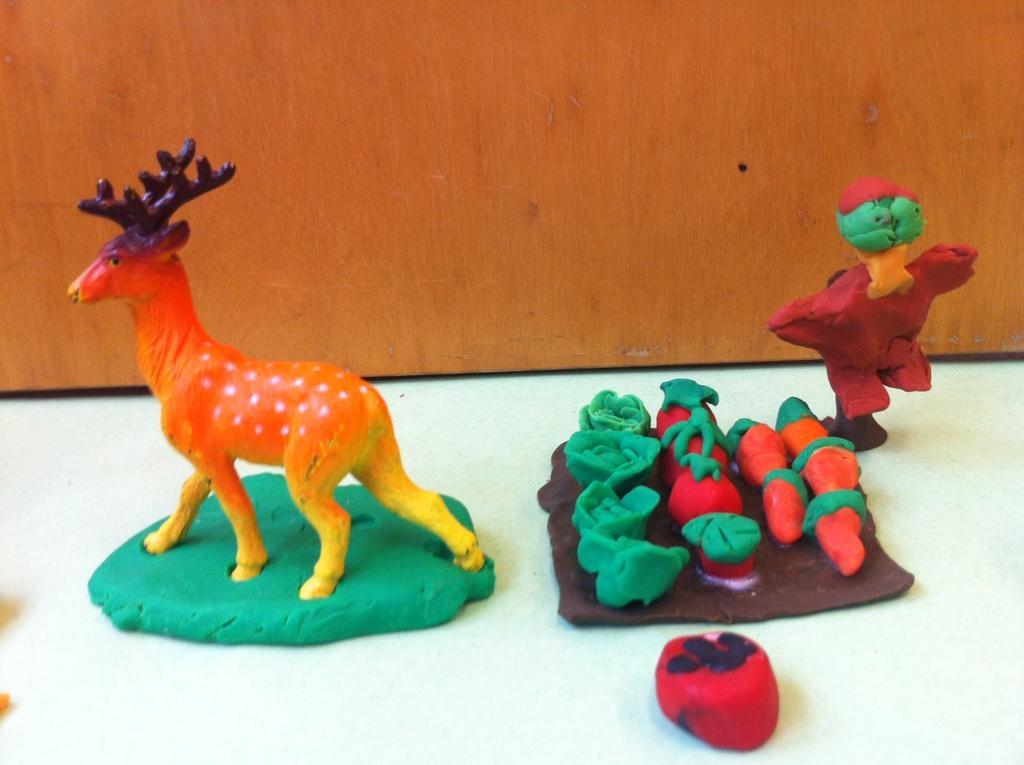Describe this image in one or two sentences. In the image we can see there are clay items kept on the table. There is a statue of deer made with clay and there is a plate of fruits and vegetables made with clay. 